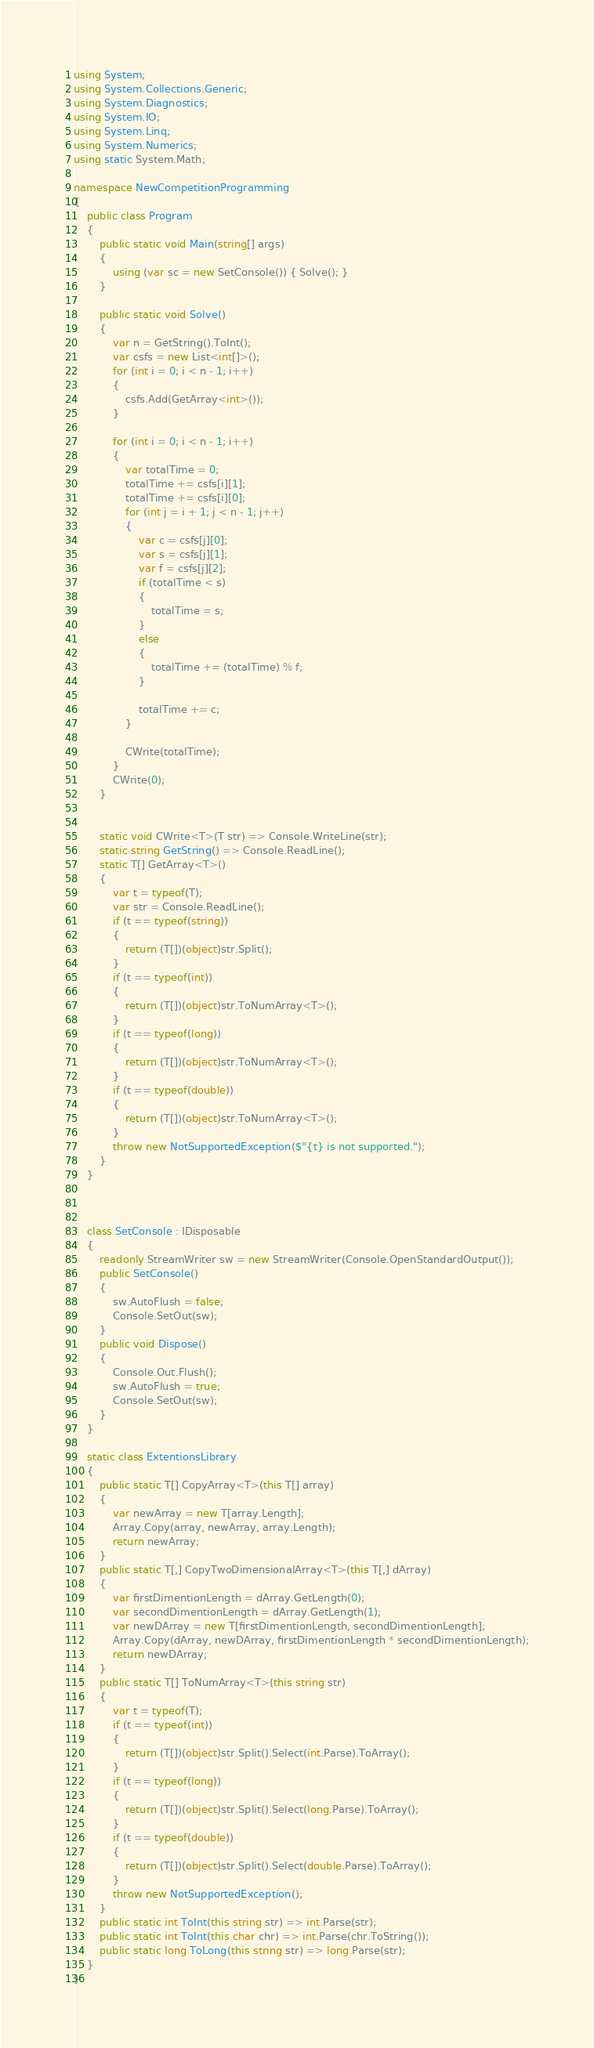<code> <loc_0><loc_0><loc_500><loc_500><_C#_>using System;
using System.Collections.Generic;
using System.Diagnostics;
using System.IO;
using System.Linq;
using System.Numerics;
using static System.Math;

namespace NewCompetitionProgramming
{
    public class Program
    {
        public static void Main(string[] args)
        {
            using (var sc = new SetConsole()) { Solve(); }
        }

        public static void Solve()
        {
            var n = GetString().ToInt();
            var csfs = new List<int[]>();
            for (int i = 0; i < n - 1; i++)
            {
                csfs.Add(GetArray<int>());
            }

            for (int i = 0; i < n - 1; i++)
            {
                var totalTime = 0;
                totalTime += csfs[i][1];
                totalTime += csfs[i][0];
                for (int j = i + 1; j < n - 1; j++)
                {
                    var c = csfs[j][0];
                    var s = csfs[j][1];
                    var f = csfs[j][2];
                    if (totalTime < s)
                    {
                        totalTime = s;
                    }
                    else
                    {
                        totalTime += (totalTime) % f;
                    }

                    totalTime += c;
                }

                CWrite(totalTime);
            }
            CWrite(0);
        }


        static void CWrite<T>(T str) => Console.WriteLine(str);
        static string GetString() => Console.ReadLine();
        static T[] GetArray<T>()
        {
            var t = typeof(T);
            var str = Console.ReadLine();
            if (t == typeof(string))
            {
                return (T[])(object)str.Split();
            }
            if (t == typeof(int))
            {
                return (T[])(object)str.ToNumArray<T>();
            }
            if (t == typeof(long))
            {
                return (T[])(object)str.ToNumArray<T>();
            }
            if (t == typeof(double))
            {
                return (T[])(object)str.ToNumArray<T>();
            }
            throw new NotSupportedException($"{t} is not supported.");
        }
    }



    class SetConsole : IDisposable
    {
        readonly StreamWriter sw = new StreamWriter(Console.OpenStandardOutput());
        public SetConsole()
        {
            sw.AutoFlush = false;
            Console.SetOut(sw);
        }
        public void Dispose()
        {
            Console.Out.Flush();
            sw.AutoFlush = true;
            Console.SetOut(sw);
        }
    }

    static class ExtentionsLibrary
    {
        public static T[] CopyArray<T>(this T[] array)
        {
            var newArray = new T[array.Length];
            Array.Copy(array, newArray, array.Length);
            return newArray;
        }
        public static T[,] CopyTwoDimensionalArray<T>(this T[,] dArray)
        {
            var firstDimentionLength = dArray.GetLength(0);
            var secondDimentionLength = dArray.GetLength(1);
            var newDArray = new T[firstDimentionLength, secondDimentionLength];
            Array.Copy(dArray, newDArray, firstDimentionLength * secondDimentionLength);
            return newDArray;
        }
        public static T[] ToNumArray<T>(this string str)
        {
            var t = typeof(T);
            if (t == typeof(int))
            {
                return (T[])(object)str.Split().Select(int.Parse).ToArray();
            }
            if (t == typeof(long))
            {
                return (T[])(object)str.Split().Select(long.Parse).ToArray();
            }
            if (t == typeof(double))
            {
                return (T[])(object)str.Split().Select(double.Parse).ToArray();
            }
            throw new NotSupportedException();
        }
        public static int ToInt(this string str) => int.Parse(str);
        public static int ToInt(this char chr) => int.Parse(chr.ToString());
        public static long ToLong(this string str) => long.Parse(str);
    }
}
</code> 